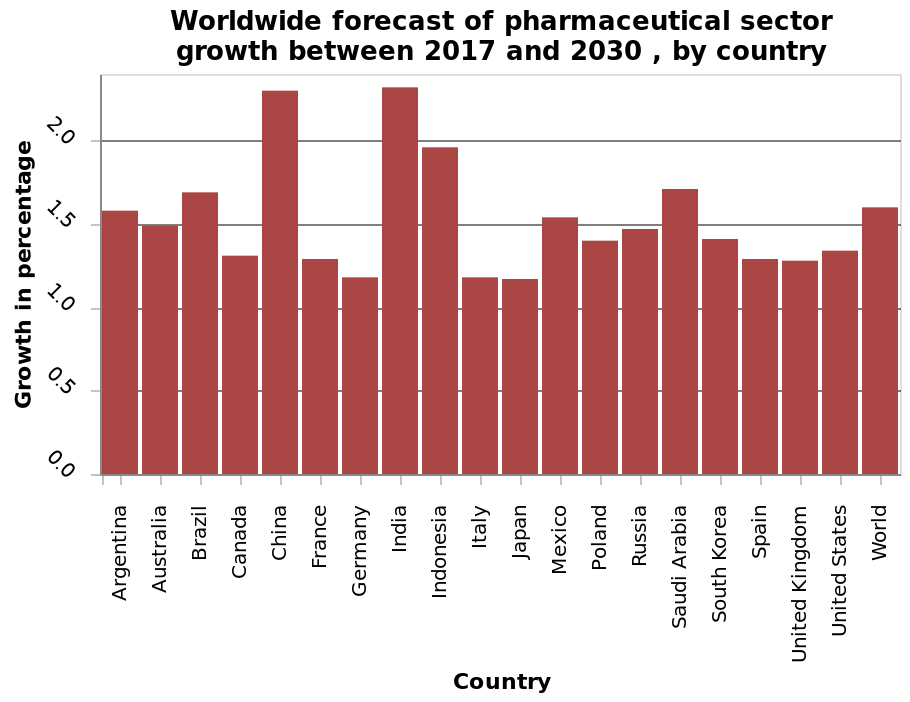<image>
What is the range of the y-axis? The range of the y-axis is from 0.0 to 2.0. Are there any countries that are predicted to have no growth? No, there is no country that appears not to have some growth. Which countries are predicted to have the biggest growth? China and India are predicted to have the biggest growth. What does the y-axis of the bar graph represent? The y-axis measures the growth in percentage on a linear scale. Is the range of the y-axis from 2.0 to 0.0? No.The range of the y-axis is from 0.0 to 2.0. 